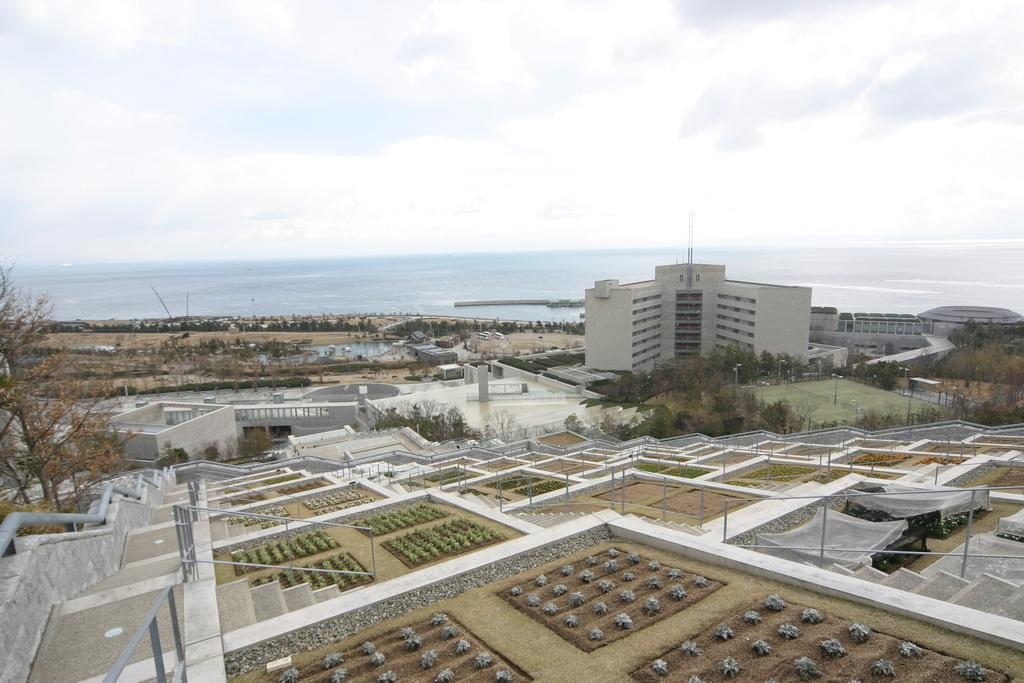What type of vegetation can be seen on the ground in the image? There are plants on the ground in the image. What architectural feature is present in the image? There are steps in the image. What can be seen hanging or worn in the image? Clothes are visible in the image. What safety feature is present in the image? Railings are present in the image. What vertical structures are present in the image? Poles are present in the image. What type of natural environment is visible in the image? There are trees in the image. What type of man-made structures are visible in the image? Buildings are visible in the image. What type of water feature is visible in the image? There is water visible in the image. What objects are present in the image? There are some objects in the image. What is visible in the background of the image? The sky is visible in the background of the image. What atmospheric feature is present in the sky? Clouds are present in the sky. Where can the scissors be found in the image? There are no scissors present in the image. What type of humor can be seen in the image? There is no humor depicted in the image. What type of pot is visible in the image? There is no pot present in the image. 